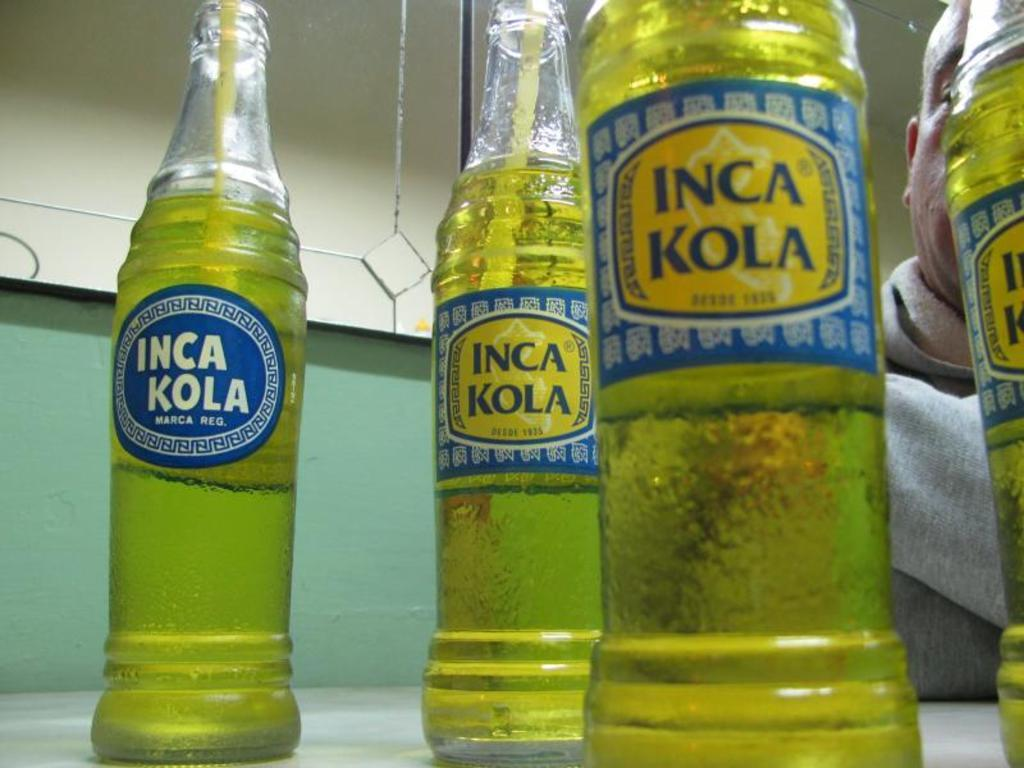<image>
Provide a brief description of the given image. Bottles of Inca Cola with two different designs sit on a table. 